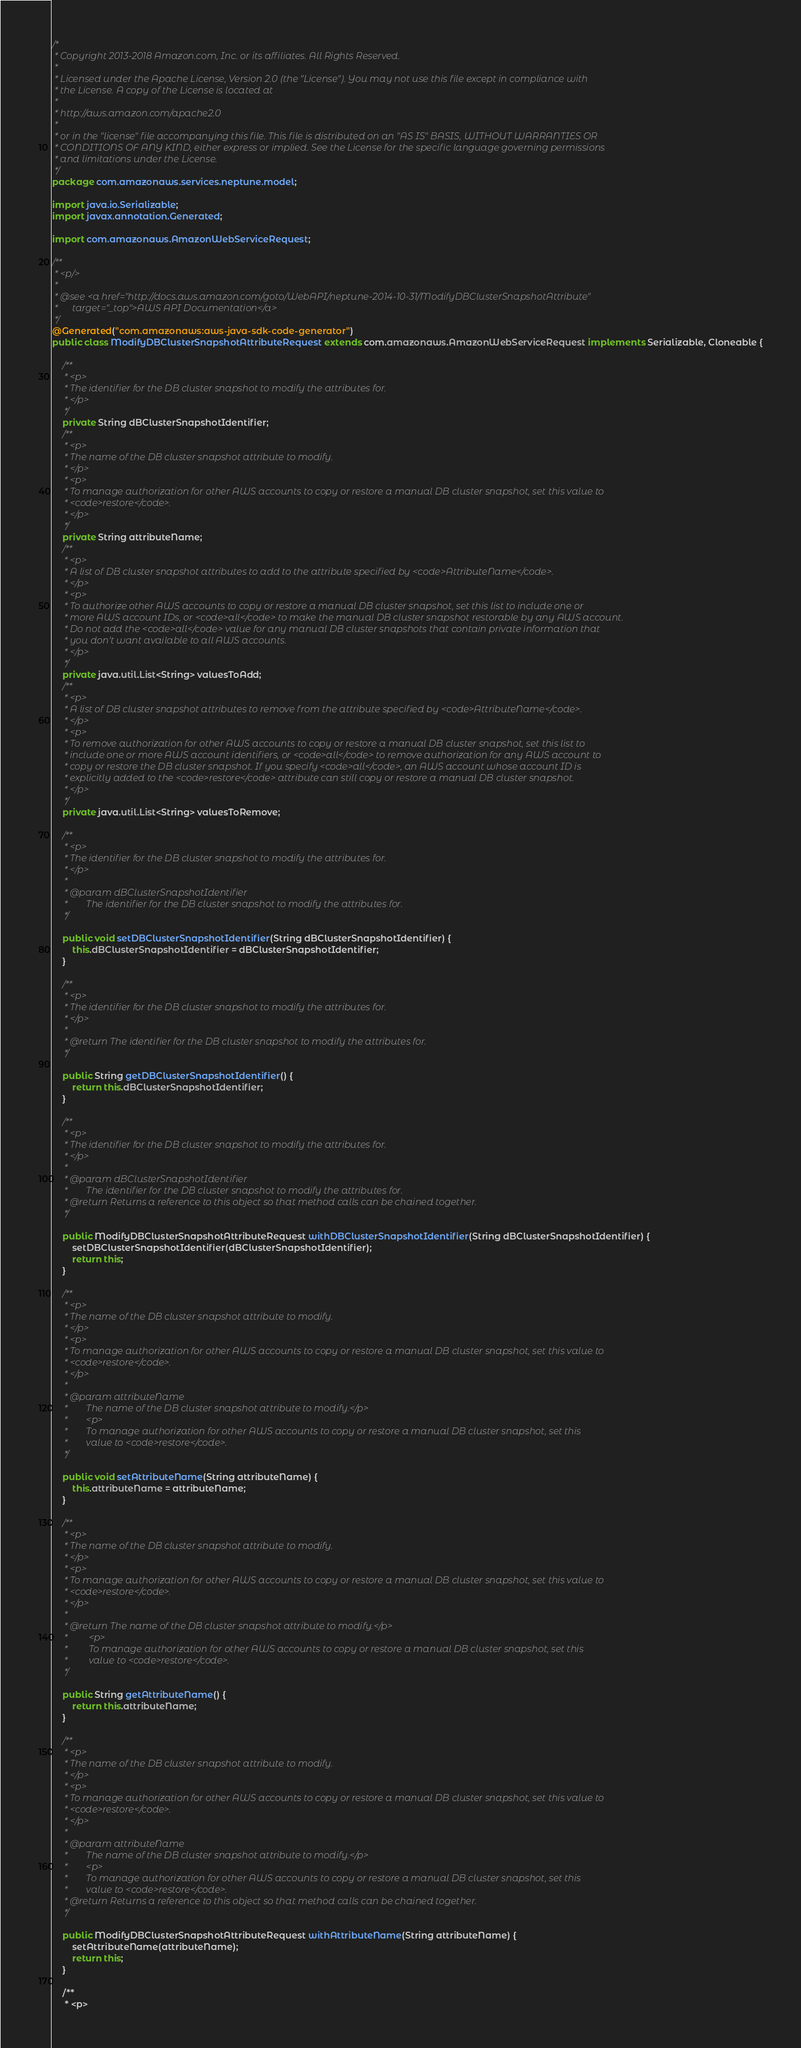<code> <loc_0><loc_0><loc_500><loc_500><_Java_>/*
 * Copyright 2013-2018 Amazon.com, Inc. or its affiliates. All Rights Reserved.
 * 
 * Licensed under the Apache License, Version 2.0 (the "License"). You may not use this file except in compliance with
 * the License. A copy of the License is located at
 * 
 * http://aws.amazon.com/apache2.0
 * 
 * or in the "license" file accompanying this file. This file is distributed on an "AS IS" BASIS, WITHOUT WARRANTIES OR
 * CONDITIONS OF ANY KIND, either express or implied. See the License for the specific language governing permissions
 * and limitations under the License.
 */
package com.amazonaws.services.neptune.model;

import java.io.Serializable;
import javax.annotation.Generated;

import com.amazonaws.AmazonWebServiceRequest;

/**
 * <p/>
 * 
 * @see <a href="http://docs.aws.amazon.com/goto/WebAPI/neptune-2014-10-31/ModifyDBClusterSnapshotAttribute"
 *      target="_top">AWS API Documentation</a>
 */
@Generated("com.amazonaws:aws-java-sdk-code-generator")
public class ModifyDBClusterSnapshotAttributeRequest extends com.amazonaws.AmazonWebServiceRequest implements Serializable, Cloneable {

    /**
     * <p>
     * The identifier for the DB cluster snapshot to modify the attributes for.
     * </p>
     */
    private String dBClusterSnapshotIdentifier;
    /**
     * <p>
     * The name of the DB cluster snapshot attribute to modify.
     * </p>
     * <p>
     * To manage authorization for other AWS accounts to copy or restore a manual DB cluster snapshot, set this value to
     * <code>restore</code>.
     * </p>
     */
    private String attributeName;
    /**
     * <p>
     * A list of DB cluster snapshot attributes to add to the attribute specified by <code>AttributeName</code>.
     * </p>
     * <p>
     * To authorize other AWS accounts to copy or restore a manual DB cluster snapshot, set this list to include one or
     * more AWS account IDs, or <code>all</code> to make the manual DB cluster snapshot restorable by any AWS account.
     * Do not add the <code>all</code> value for any manual DB cluster snapshots that contain private information that
     * you don't want available to all AWS accounts.
     * </p>
     */
    private java.util.List<String> valuesToAdd;
    /**
     * <p>
     * A list of DB cluster snapshot attributes to remove from the attribute specified by <code>AttributeName</code>.
     * </p>
     * <p>
     * To remove authorization for other AWS accounts to copy or restore a manual DB cluster snapshot, set this list to
     * include one or more AWS account identifiers, or <code>all</code> to remove authorization for any AWS account to
     * copy or restore the DB cluster snapshot. If you specify <code>all</code>, an AWS account whose account ID is
     * explicitly added to the <code>restore</code> attribute can still copy or restore a manual DB cluster snapshot.
     * </p>
     */
    private java.util.List<String> valuesToRemove;

    /**
     * <p>
     * The identifier for the DB cluster snapshot to modify the attributes for.
     * </p>
     * 
     * @param dBClusterSnapshotIdentifier
     *        The identifier for the DB cluster snapshot to modify the attributes for.
     */

    public void setDBClusterSnapshotIdentifier(String dBClusterSnapshotIdentifier) {
        this.dBClusterSnapshotIdentifier = dBClusterSnapshotIdentifier;
    }

    /**
     * <p>
     * The identifier for the DB cluster snapshot to modify the attributes for.
     * </p>
     * 
     * @return The identifier for the DB cluster snapshot to modify the attributes for.
     */

    public String getDBClusterSnapshotIdentifier() {
        return this.dBClusterSnapshotIdentifier;
    }

    /**
     * <p>
     * The identifier for the DB cluster snapshot to modify the attributes for.
     * </p>
     * 
     * @param dBClusterSnapshotIdentifier
     *        The identifier for the DB cluster snapshot to modify the attributes for.
     * @return Returns a reference to this object so that method calls can be chained together.
     */

    public ModifyDBClusterSnapshotAttributeRequest withDBClusterSnapshotIdentifier(String dBClusterSnapshotIdentifier) {
        setDBClusterSnapshotIdentifier(dBClusterSnapshotIdentifier);
        return this;
    }

    /**
     * <p>
     * The name of the DB cluster snapshot attribute to modify.
     * </p>
     * <p>
     * To manage authorization for other AWS accounts to copy or restore a manual DB cluster snapshot, set this value to
     * <code>restore</code>.
     * </p>
     * 
     * @param attributeName
     *        The name of the DB cluster snapshot attribute to modify.</p>
     *        <p>
     *        To manage authorization for other AWS accounts to copy or restore a manual DB cluster snapshot, set this
     *        value to <code>restore</code>.
     */

    public void setAttributeName(String attributeName) {
        this.attributeName = attributeName;
    }

    /**
     * <p>
     * The name of the DB cluster snapshot attribute to modify.
     * </p>
     * <p>
     * To manage authorization for other AWS accounts to copy or restore a manual DB cluster snapshot, set this value to
     * <code>restore</code>.
     * </p>
     * 
     * @return The name of the DB cluster snapshot attribute to modify.</p>
     *         <p>
     *         To manage authorization for other AWS accounts to copy or restore a manual DB cluster snapshot, set this
     *         value to <code>restore</code>.
     */

    public String getAttributeName() {
        return this.attributeName;
    }

    /**
     * <p>
     * The name of the DB cluster snapshot attribute to modify.
     * </p>
     * <p>
     * To manage authorization for other AWS accounts to copy or restore a manual DB cluster snapshot, set this value to
     * <code>restore</code>.
     * </p>
     * 
     * @param attributeName
     *        The name of the DB cluster snapshot attribute to modify.</p>
     *        <p>
     *        To manage authorization for other AWS accounts to copy or restore a manual DB cluster snapshot, set this
     *        value to <code>restore</code>.
     * @return Returns a reference to this object so that method calls can be chained together.
     */

    public ModifyDBClusterSnapshotAttributeRequest withAttributeName(String attributeName) {
        setAttributeName(attributeName);
        return this;
    }

    /**
     * <p></code> 